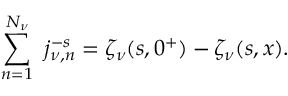<formula> <loc_0><loc_0><loc_500><loc_500>\sum _ { n = 1 } ^ { N _ { \nu } } \ j _ { \nu , n } ^ { - s } = \zeta _ { \nu } ( s , 0 ^ { + } ) - \zeta _ { \nu } ( s , x ) .</formula> 